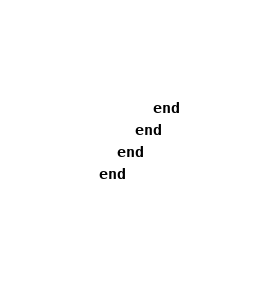Convert code to text. <code><loc_0><loc_0><loc_500><loc_500><_Ruby_>      end
    end
  end
end
</code> 